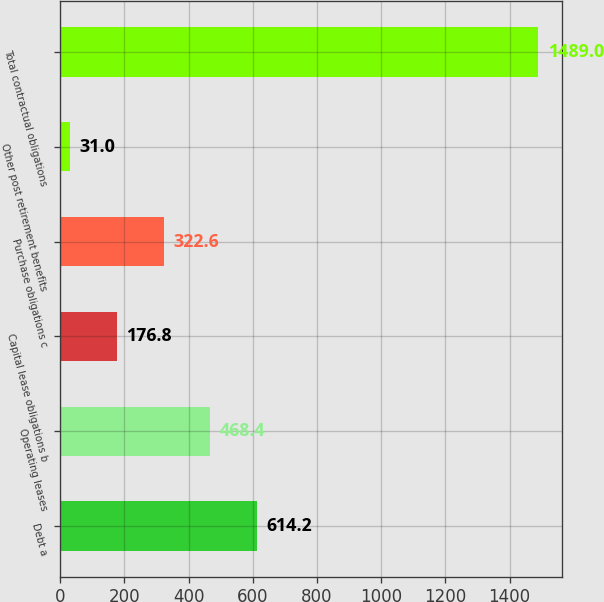Convert chart to OTSL. <chart><loc_0><loc_0><loc_500><loc_500><bar_chart><fcel>Debt a<fcel>Operating leases<fcel>Capital lease obligations b<fcel>Purchase obligations c<fcel>Other post retirement benefits<fcel>Total contractual obligations<nl><fcel>614.2<fcel>468.4<fcel>176.8<fcel>322.6<fcel>31<fcel>1489<nl></chart> 